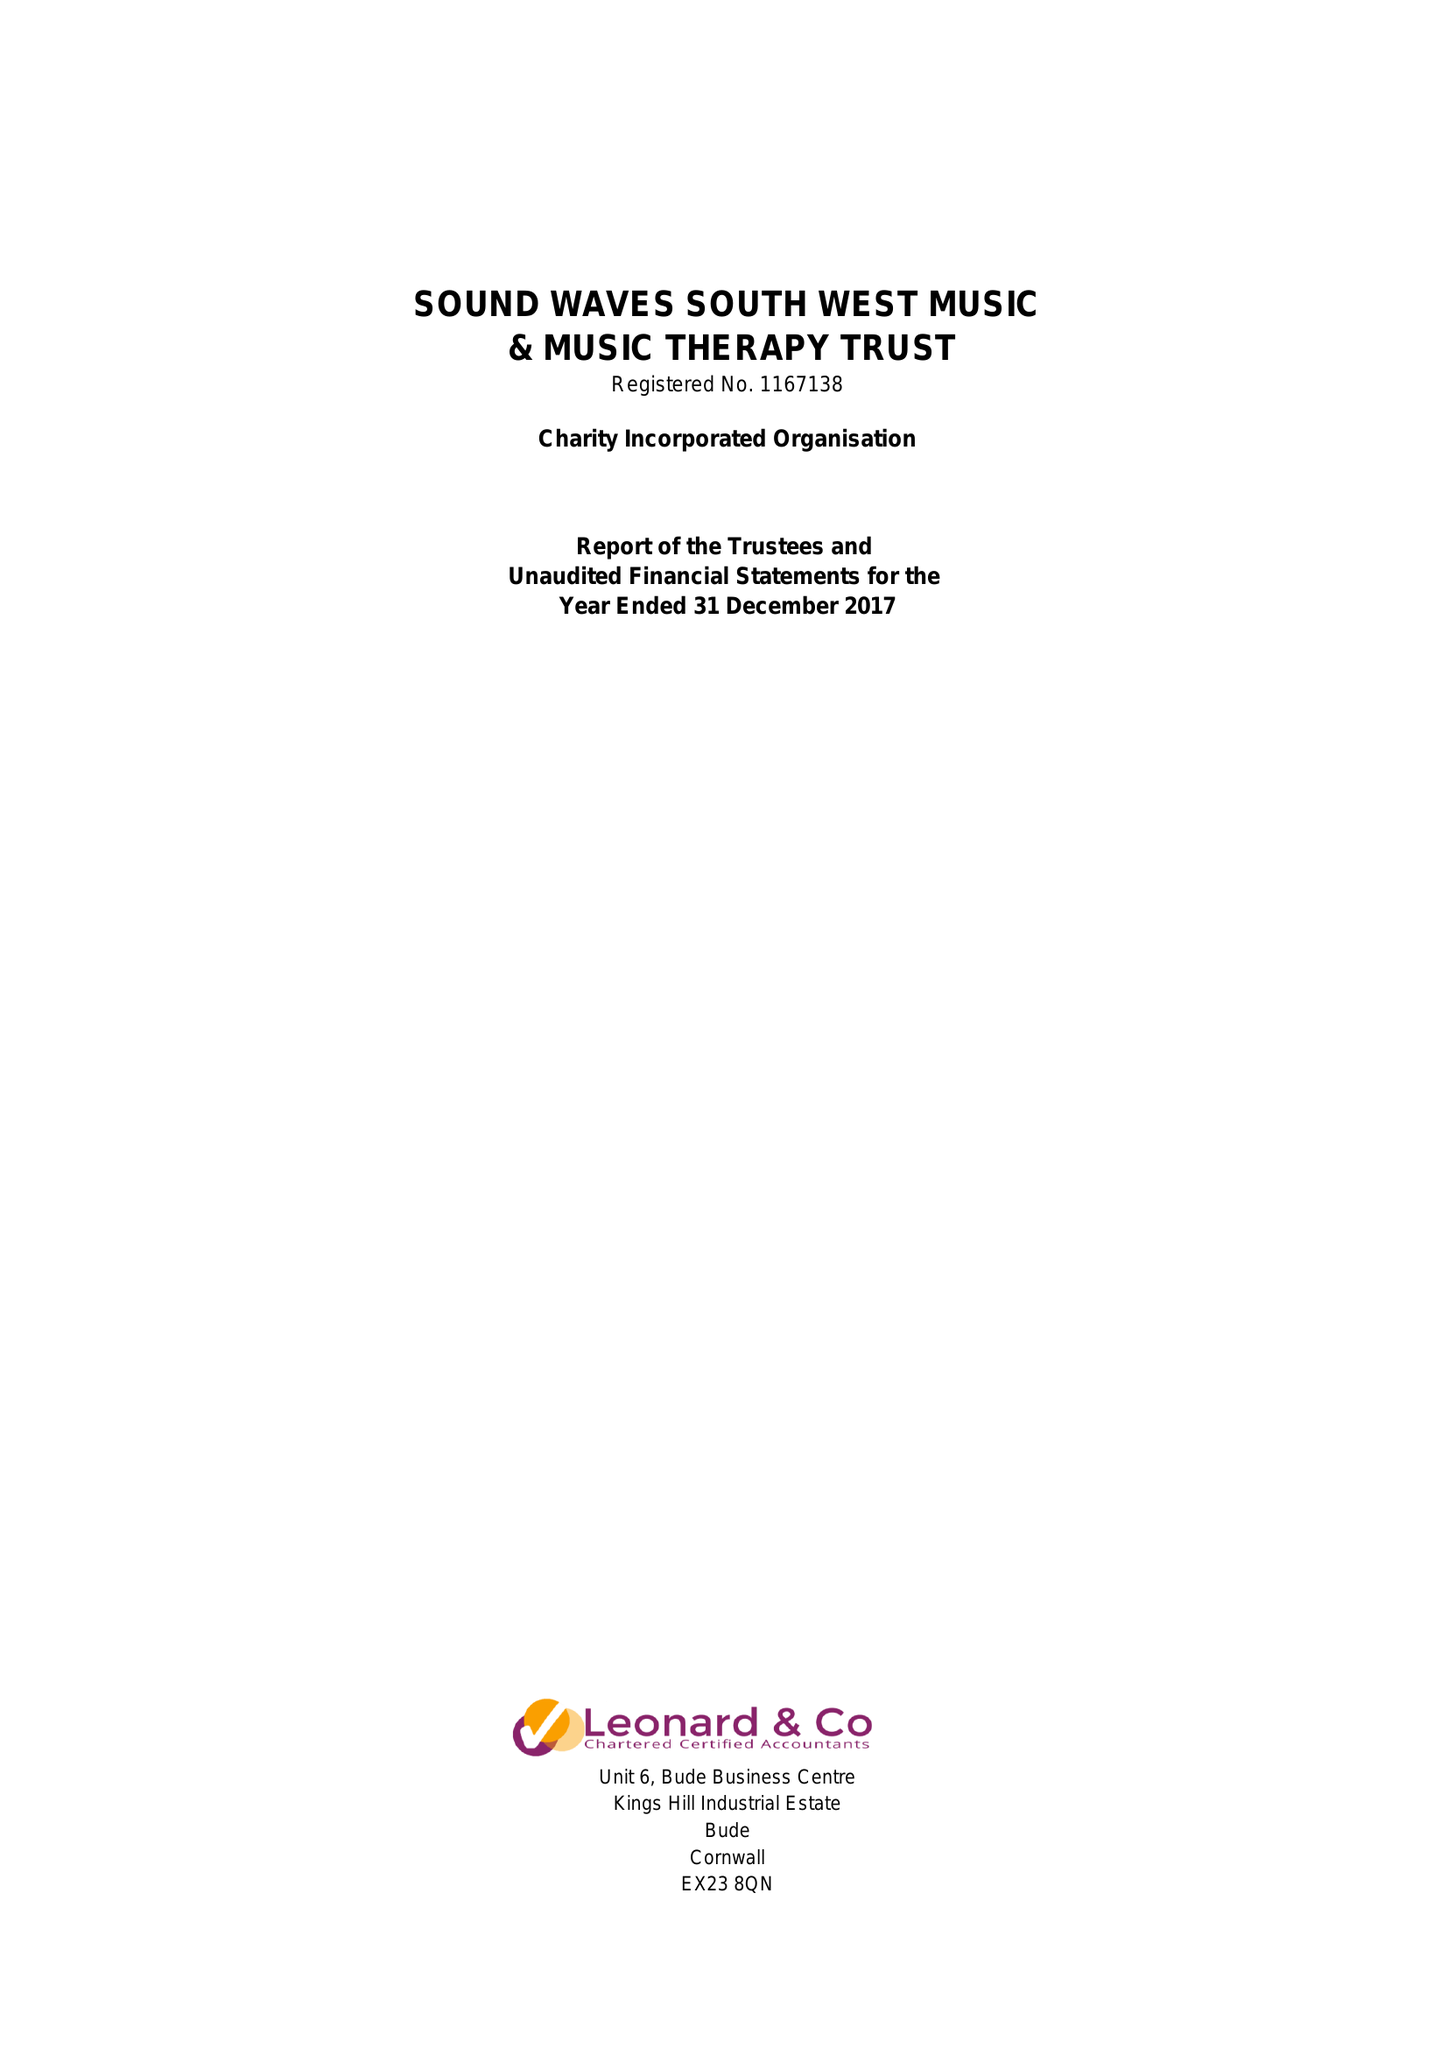What is the value for the address__post_town?
Answer the question using a single word or phrase. BUDE 